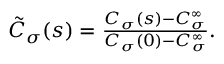<formula> <loc_0><loc_0><loc_500><loc_500>\begin{array} { r } { \tilde { C } _ { \sigma } ( s ) = \frac { C _ { \sigma } ( s ) - C _ { \sigma } ^ { \infty } } { C _ { \sigma } ( 0 ) - C _ { \sigma } ^ { \infty } } . } \end{array}</formula> 